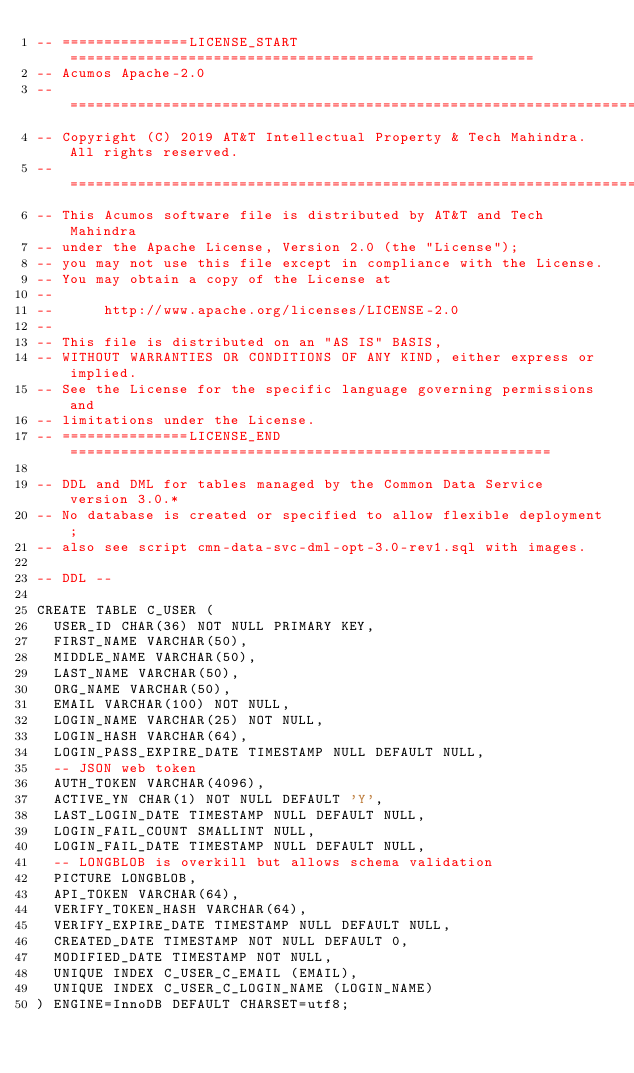Convert code to text. <code><loc_0><loc_0><loc_500><loc_500><_SQL_>-- ===============LICENSE_START=======================================================
-- Acumos Apache-2.0
-- ===================================================================================
-- Copyright (C) 2019 AT&T Intellectual Property & Tech Mahindra. All rights reserved.
-- ===================================================================================
-- This Acumos software file is distributed by AT&T and Tech Mahindra
-- under the Apache License, Version 2.0 (the "License");
-- you may not use this file except in compliance with the License.
-- You may obtain a copy of the License at
--
--      http://www.apache.org/licenses/LICENSE-2.0
--
-- This file is distributed on an "AS IS" BASIS,
-- WITHOUT WARRANTIES OR CONDITIONS OF ANY KIND, either express or implied.
-- See the License for the specific language governing permissions and
-- limitations under the License.
-- ===============LICENSE_END=========================================================

-- DDL and DML for tables managed by the Common Data Service version 3.0.*
-- No database is created or specified to allow flexible deployment;
-- also see script cmn-data-svc-dml-opt-3.0-rev1.sql with images.

-- DDL --

CREATE TABLE C_USER (
  USER_ID CHAR(36) NOT NULL PRIMARY KEY,
  FIRST_NAME VARCHAR(50),
  MIDDLE_NAME VARCHAR(50),
  LAST_NAME VARCHAR(50),
  ORG_NAME VARCHAR(50),
  EMAIL VARCHAR(100) NOT NULL,
  LOGIN_NAME VARCHAR(25) NOT NULL,
  LOGIN_HASH VARCHAR(64),
  LOGIN_PASS_EXPIRE_DATE TIMESTAMP NULL DEFAULT NULL,
  -- JSON web token
  AUTH_TOKEN VARCHAR(4096),
  ACTIVE_YN CHAR(1) NOT NULL DEFAULT 'Y',
  LAST_LOGIN_DATE TIMESTAMP NULL DEFAULT NULL,
  LOGIN_FAIL_COUNT SMALLINT NULL,
  LOGIN_FAIL_DATE TIMESTAMP NULL DEFAULT NULL,
  -- LONGBLOB is overkill but allows schema validation
  PICTURE LONGBLOB,
  API_TOKEN VARCHAR(64),
  VERIFY_TOKEN_HASH VARCHAR(64),
  VERIFY_EXPIRE_DATE TIMESTAMP NULL DEFAULT NULL,
  CREATED_DATE TIMESTAMP NOT NULL DEFAULT 0,
  MODIFIED_DATE TIMESTAMP NOT NULL,
  UNIQUE INDEX C_USER_C_EMAIL (EMAIL),
  UNIQUE INDEX C_USER_C_LOGIN_NAME (LOGIN_NAME)
) ENGINE=InnoDB DEFAULT CHARSET=utf8;
</code> 